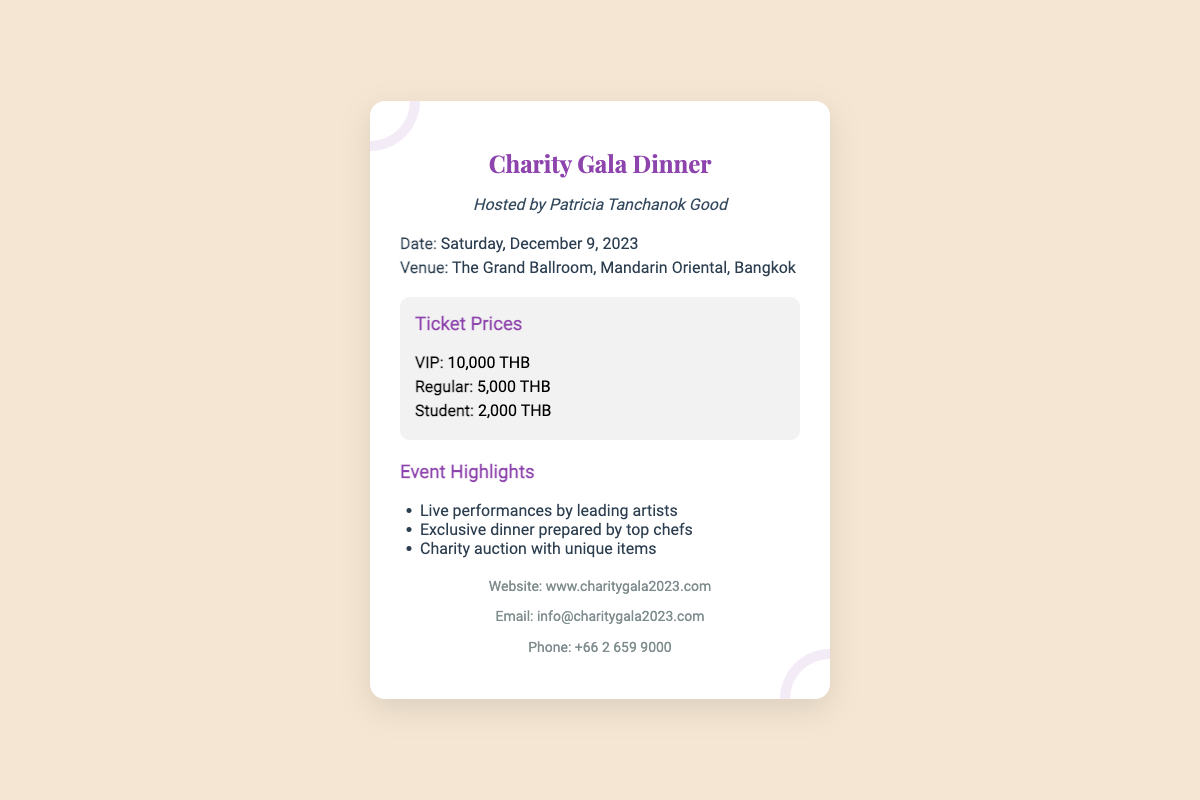what is the date of the event? The date can be found in the details section of the document, which states "Saturday, December 9, 2023."
Answer: Saturday, December 9, 2023 where is the venue located? The venue is mentioned in the details section as "The Grand Ballroom, Mandarin Oriental, Bangkok."
Answer: The Grand Ballroom, Mandarin Oriental, Bangkok what is the price of a VIP ticket? The ticket price section lists the price for a VIP ticket as "10,000 THB."
Answer: 10,000 THB which highlights are included in the event? The highlights section provides details, including live performances, exclusive dinner, and charity auction.
Answer: Live performances by leading artists, Exclusive dinner prepared by top chefs, Charity auction with unique items who is hosting the event? The host of the event is clearly indicated as "Patricia Tanchanok Good."
Answer: Patricia Tanchanok Good what is the contact email for the event? The contact information section includes the email, which is "info@charitygala2023.com."
Answer: info@charitygala2023.com how many types of tickets are offered? The ticket information section enumerates three different types: VIP, Regular, and Student.
Answer: Three what is the phone number for inquiries? The contact section provides a phone number, which is listed as "+66 2 659 9000."
Answer: +66 2 659 9000 